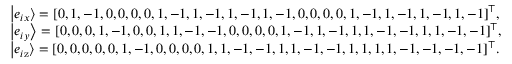<formula> <loc_0><loc_0><loc_500><loc_500>\begin{array} { l } { \left | { { e _ { i x } } } \right \rangle = { [ 0 , 1 , - 1 , 0 , 0 , 0 , 0 , 1 , - 1 , 1 , - 1 , 1 , - 1 , 1 , - 1 , 0 , 0 , 0 , 0 , 1 , - 1 , 1 , - 1 , 1 , - 1 , 1 , - 1 ] ^ { \top } } , } \\ { \left | { { e _ { i y } } } \right \rangle = { [ 0 , 0 , 0 , 1 , - 1 , 0 , 0 , 1 , 1 , - 1 , - 1 , 0 , 0 , 0 , 0 , 1 , - 1 , 1 , - 1 , 1 , 1 , - 1 , - 1 , 1 , 1 , - 1 , - 1 ] ^ { \top } } , } \\ { \left | { { e _ { i { z } } } } \right \rangle = { [ 0 , 0 , 0 , 0 , 0 , 1 , - 1 , 0 , 0 , 0 , 0 , 1 , 1 , - 1 , - 1 , 1 , 1 , - 1 , - 1 , 1 , 1 , 1 , 1 , - 1 , - 1 , - 1 , - 1 ] ^ { \top } } . } \end{array}</formula> 